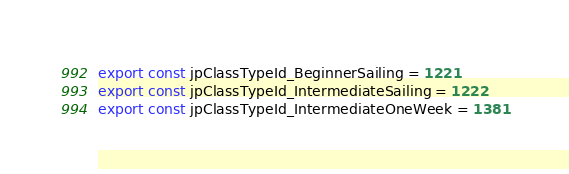<code> <loc_0><loc_0><loc_500><loc_500><_TypeScript_>export const jpClassTypeId_BeginnerSailing = 1221
export const jpClassTypeId_IntermediateSailing = 1222
export const jpClassTypeId_IntermediateOneWeek = 1381</code> 